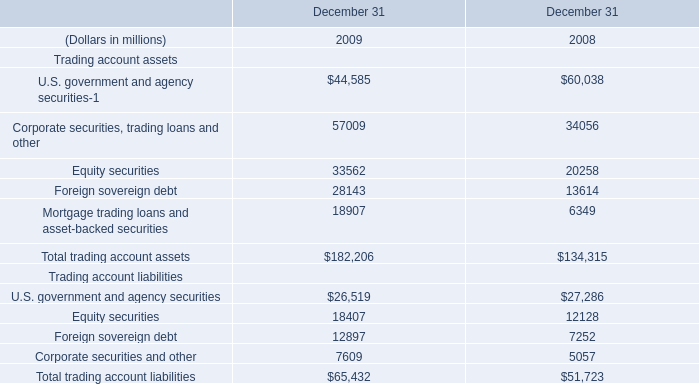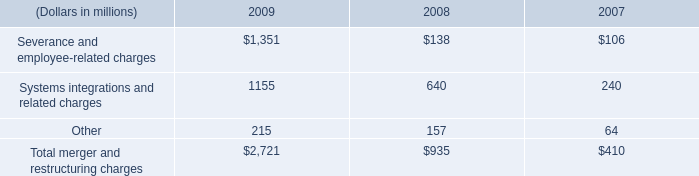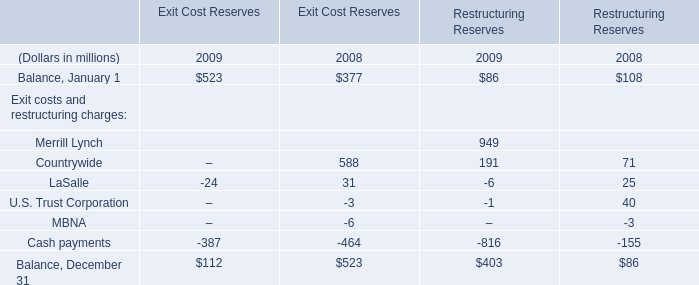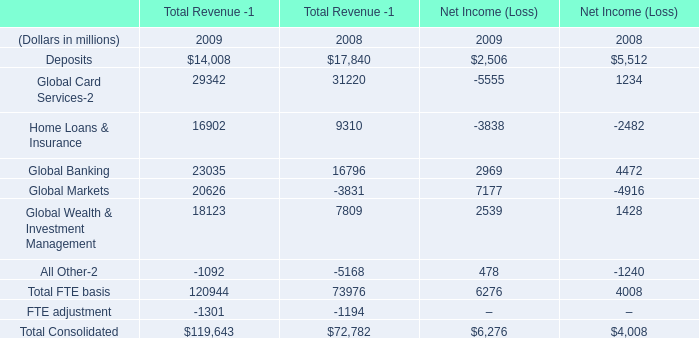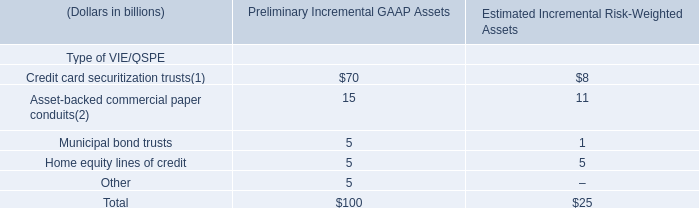What will total merger and restructuring charges be like in 2010 if it develops with the same increasing rate as current? (in dollars in millions) 
Computations: (2721 * (1 + ((2721 - 935) / 935)))
Answer: 7918.54652. 